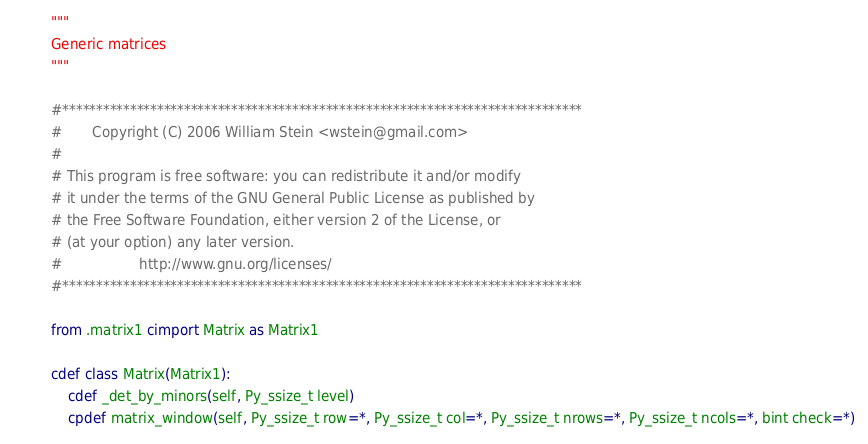Convert code to text. <code><loc_0><loc_0><loc_500><loc_500><_Cython_>"""
Generic matrices
"""

#*****************************************************************************
#       Copyright (C) 2006 William Stein <wstein@gmail.com>
#
# This program is free software: you can redistribute it and/or modify
# it under the terms of the GNU General Public License as published by
# the Free Software Foundation, either version 2 of the License, or
# (at your option) any later version.
#                  http://www.gnu.org/licenses/
#*****************************************************************************

from .matrix1 cimport Matrix as Matrix1

cdef class Matrix(Matrix1):
    cdef _det_by_minors(self, Py_ssize_t level)
    cpdef matrix_window(self, Py_ssize_t row=*, Py_ssize_t col=*, Py_ssize_t nrows=*, Py_ssize_t ncols=*, bint check=*)
</code> 